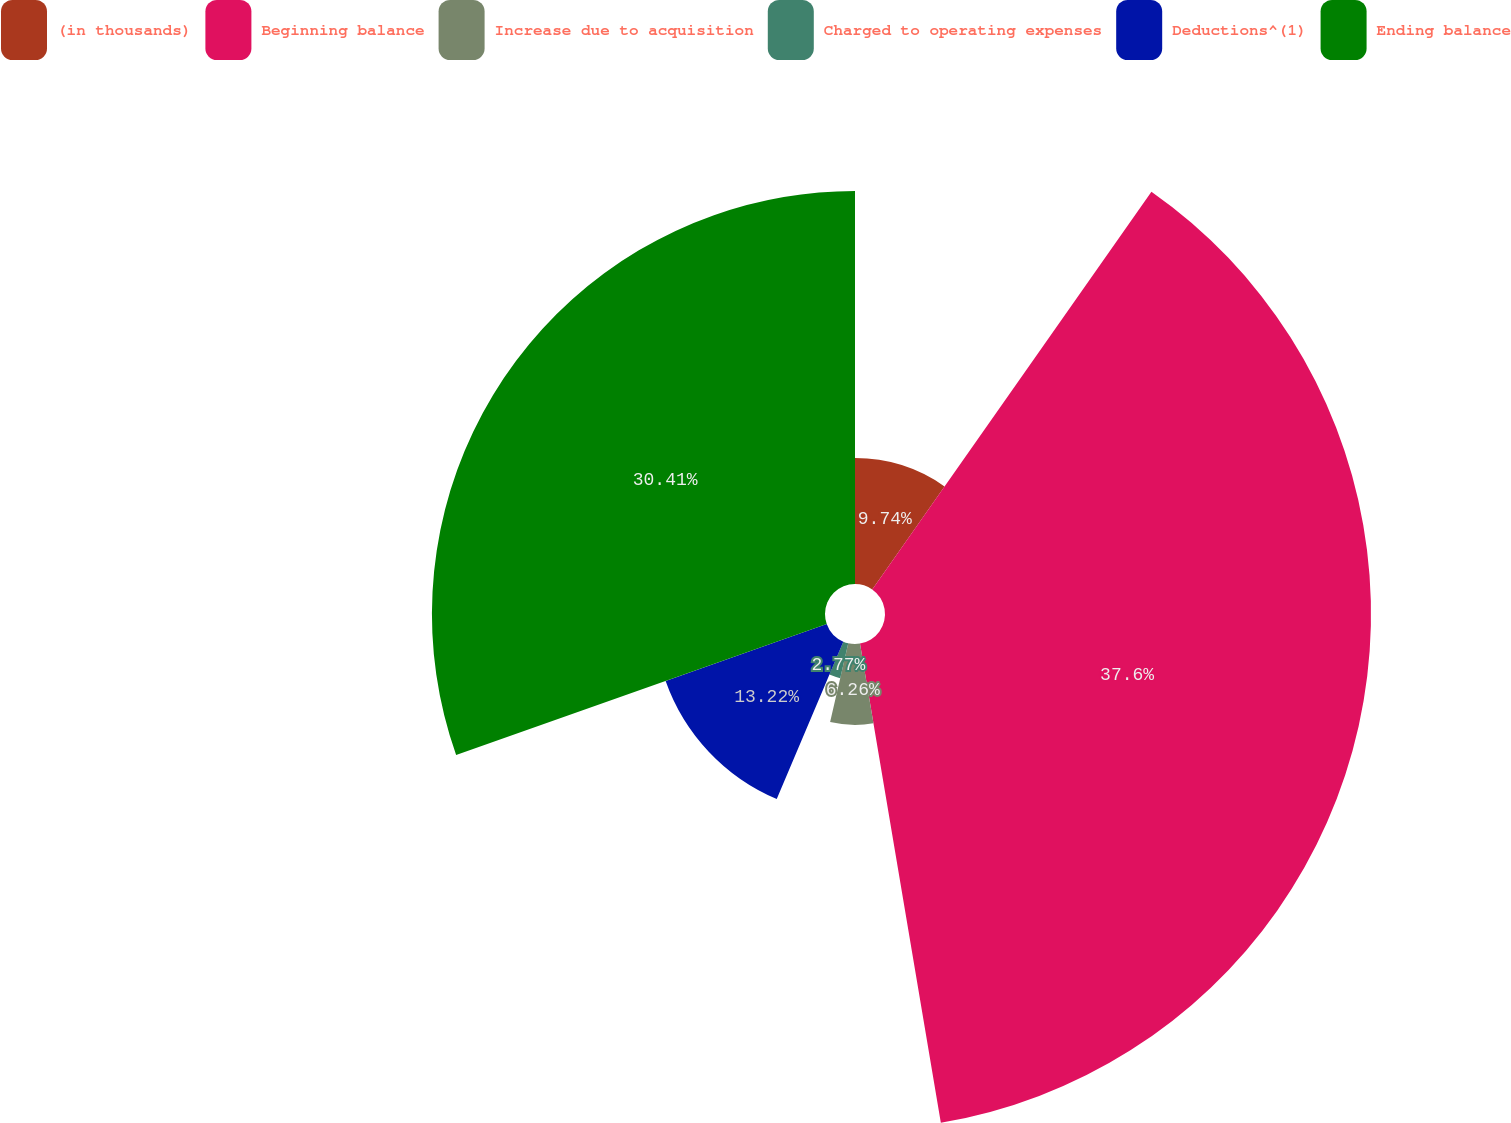<chart> <loc_0><loc_0><loc_500><loc_500><pie_chart><fcel>(in thousands)<fcel>Beginning balance<fcel>Increase due to acquisition<fcel>Charged to operating expenses<fcel>Deductions^(1)<fcel>Ending balance<nl><fcel>9.74%<fcel>37.6%<fcel>6.26%<fcel>2.77%<fcel>13.22%<fcel>30.41%<nl></chart> 